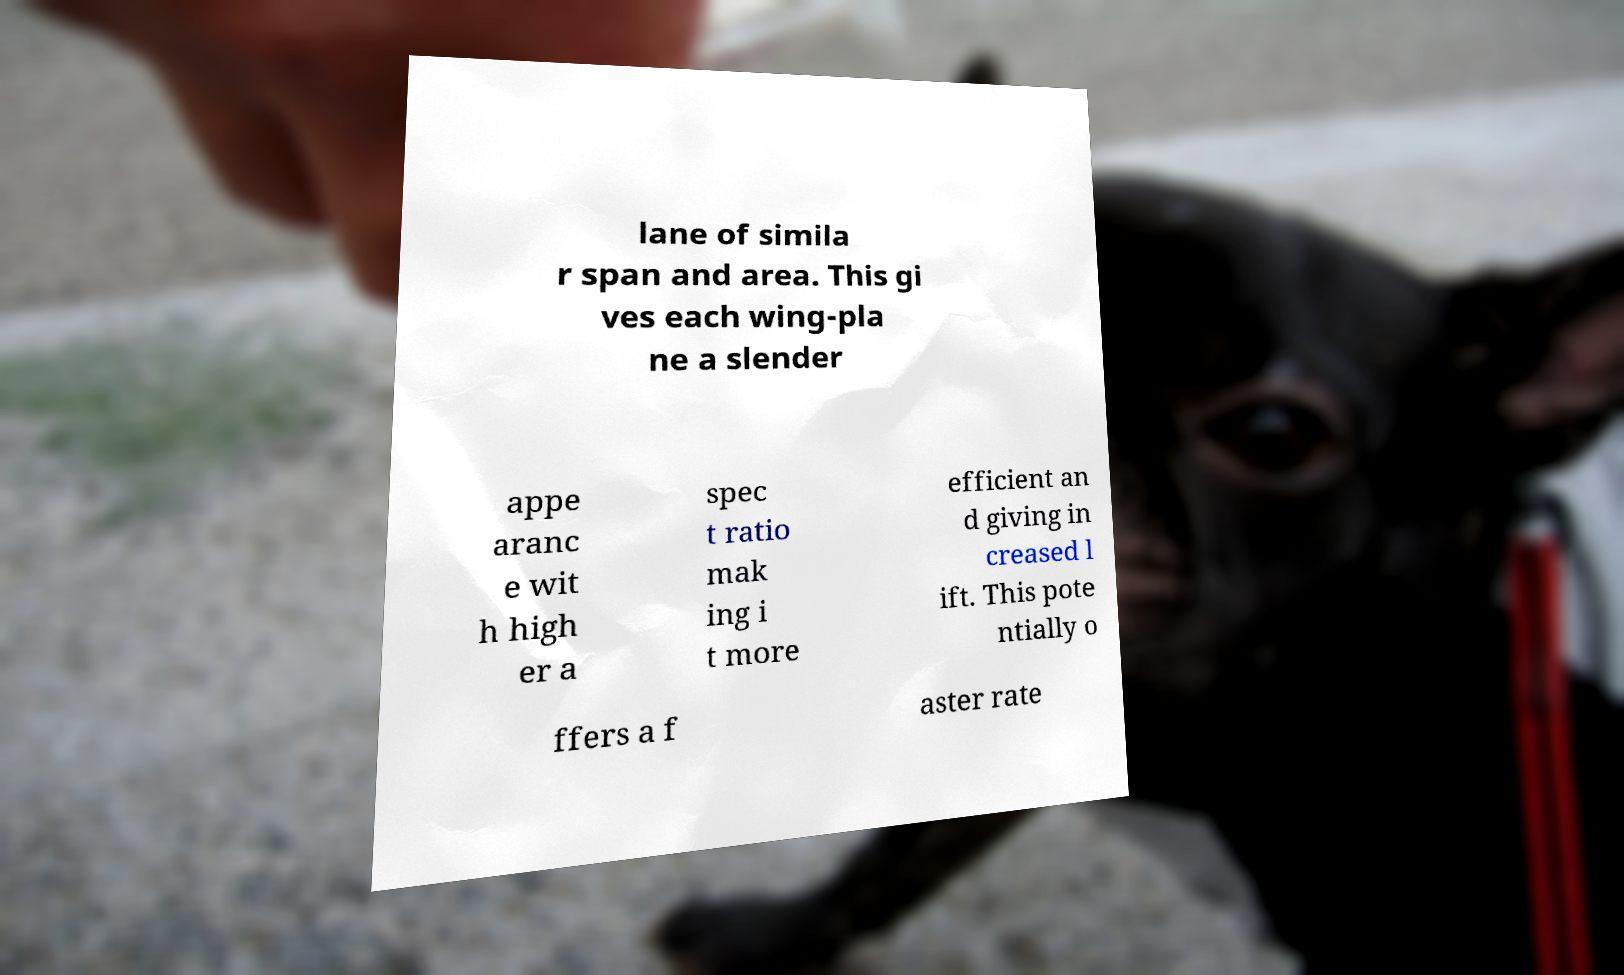Could you assist in decoding the text presented in this image and type it out clearly? lane of simila r span and area. This gi ves each wing-pla ne a slender appe aranc e wit h high er a spec t ratio mak ing i t more efficient an d giving in creased l ift. This pote ntially o ffers a f aster rate 